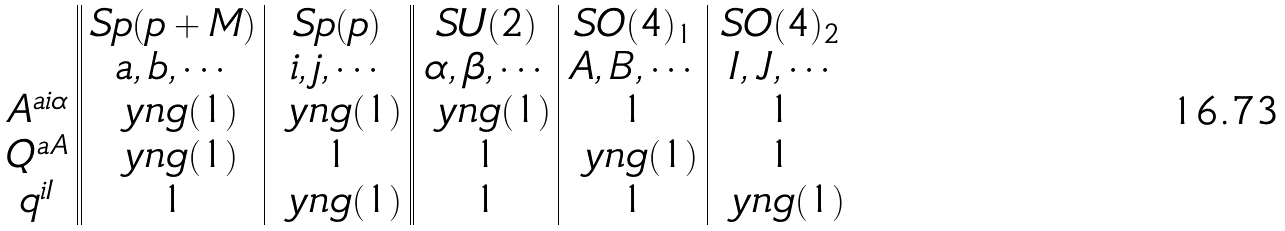Convert formula to latex. <formula><loc_0><loc_0><loc_500><loc_500>\begin{array} { c | | c | c | | c | c | c } & S p ( p + M ) & S p ( p ) & S U ( 2 ) & S O ( 4 ) _ { 1 } & S O ( 4 ) _ { 2 } \\ & a , b , \cdots & i , j , \cdots & \alpha , \beta , \cdots & A , B , \cdots & I , J , \cdots \\ A ^ { a i \alpha } & \ y n g ( 1 ) & \ y n g ( 1 ) & \ y n g ( 1 ) & 1 & 1 \\ Q ^ { a A } & \ y n g ( 1 ) & 1 & 1 & \ y n g ( 1 ) & 1 \\ q ^ { i I } & 1 & \ y n g ( 1 ) & 1 & 1 & \ y n g ( 1 ) \\ \end{array}</formula> 